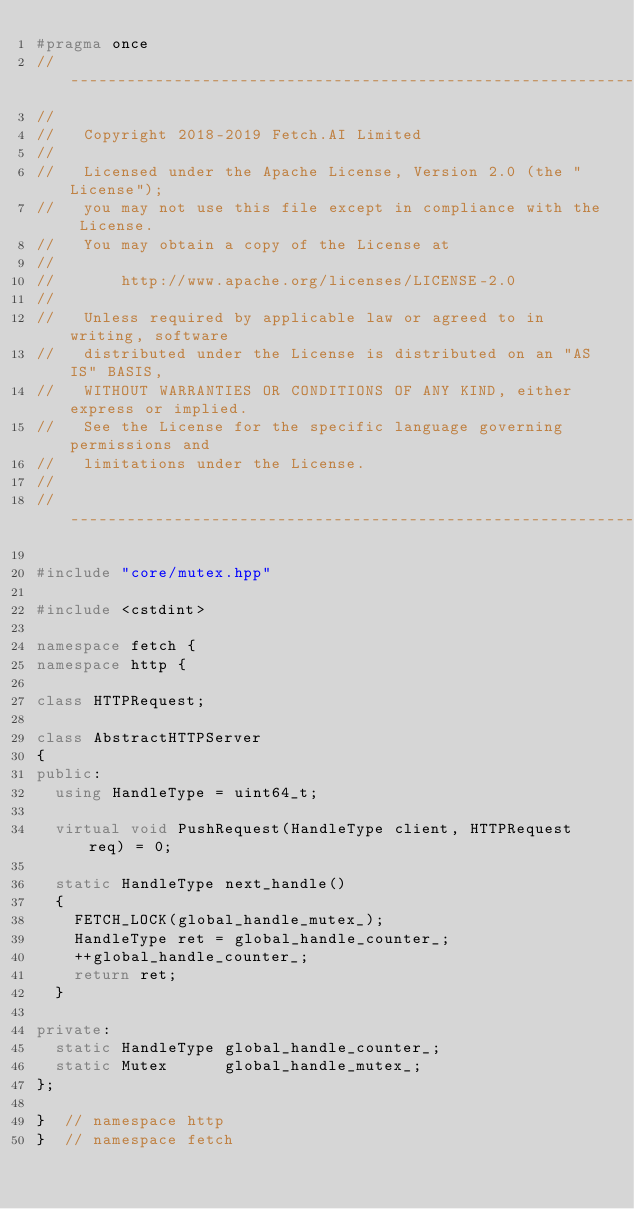Convert code to text. <code><loc_0><loc_0><loc_500><loc_500><_C++_>#pragma once
//------------------------------------------------------------------------------
//
//   Copyright 2018-2019 Fetch.AI Limited
//
//   Licensed under the Apache License, Version 2.0 (the "License");
//   you may not use this file except in compliance with the License.
//   You may obtain a copy of the License at
//
//       http://www.apache.org/licenses/LICENSE-2.0
//
//   Unless required by applicable law or agreed to in writing, software
//   distributed under the License is distributed on an "AS IS" BASIS,
//   WITHOUT WARRANTIES OR CONDITIONS OF ANY KIND, either express or implied.
//   See the License for the specific language governing permissions and
//   limitations under the License.
//
//------------------------------------------------------------------------------

#include "core/mutex.hpp"

#include <cstdint>

namespace fetch {
namespace http {

class HTTPRequest;

class AbstractHTTPServer
{
public:
  using HandleType = uint64_t;

  virtual void PushRequest(HandleType client, HTTPRequest req) = 0;

  static HandleType next_handle()
  {
    FETCH_LOCK(global_handle_mutex_);
    HandleType ret = global_handle_counter_;
    ++global_handle_counter_;
    return ret;
  }

private:
  static HandleType global_handle_counter_;
  static Mutex      global_handle_mutex_;
};

}  // namespace http
}  // namespace fetch
</code> 